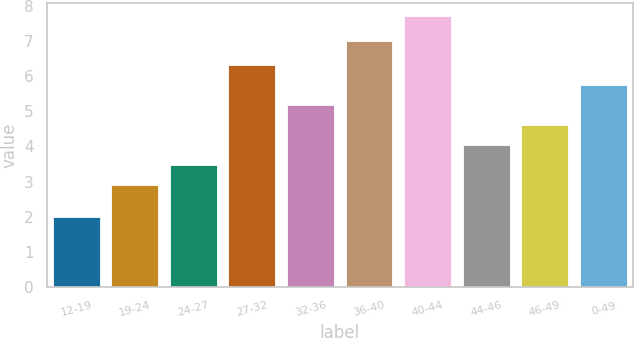Convert chart to OTSL. <chart><loc_0><loc_0><loc_500><loc_500><bar_chart><fcel>12-19<fcel>19-24<fcel>24-27<fcel>27-32<fcel>32-36<fcel>36-40<fcel>40-44<fcel>44-46<fcel>46-49<fcel>0-49<nl><fcel>2<fcel>2.9<fcel>3.47<fcel>6.32<fcel>5.18<fcel>7<fcel>7.7<fcel>4.04<fcel>4.61<fcel>5.75<nl></chart> 